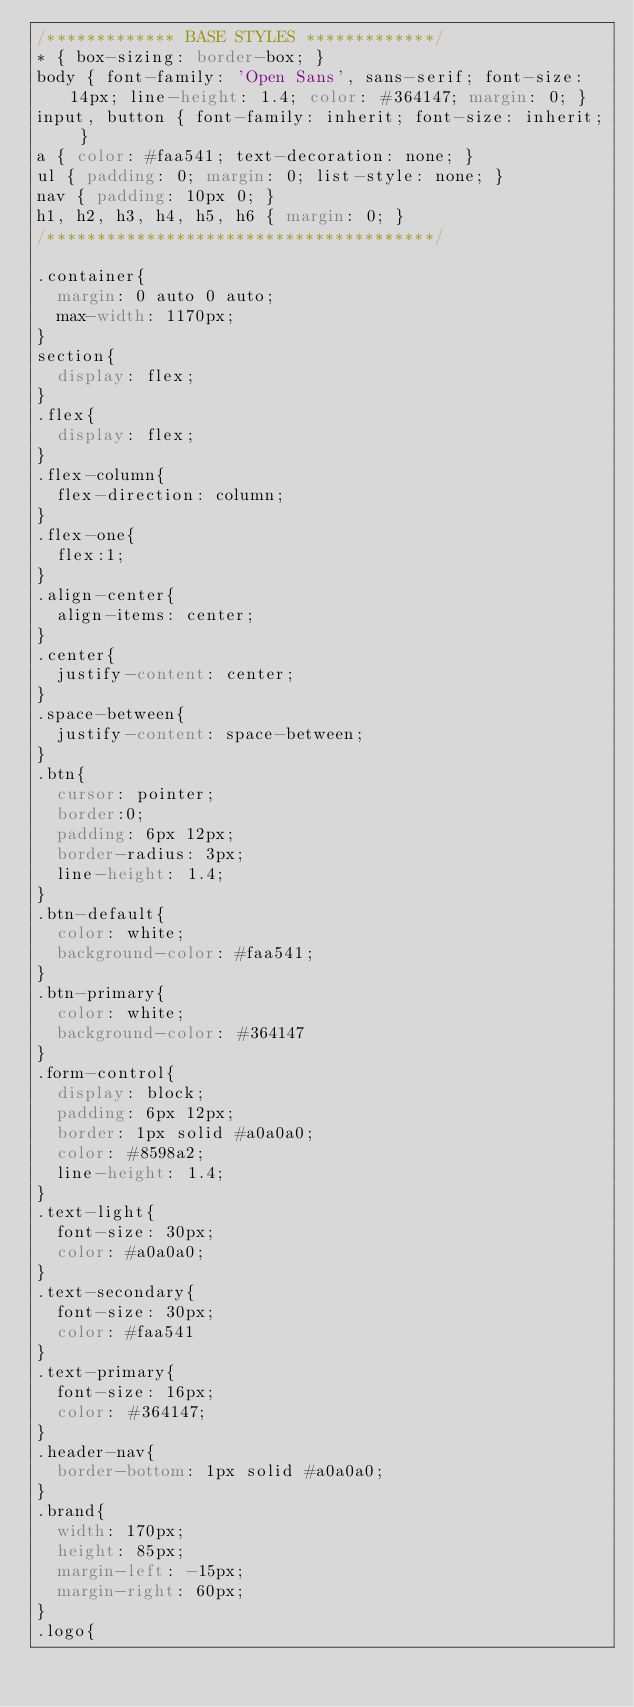<code> <loc_0><loc_0><loc_500><loc_500><_CSS_>/************* BASE STYLES *************/
* { box-sizing: border-box; }
body { font-family: 'Open Sans', sans-serif; font-size: 14px; line-height: 1.4; color: #364147; margin: 0; }
input, button { font-family: inherit; font-size: inherit; }
a { color: #faa541; text-decoration: none; }
ul { padding: 0; margin: 0; list-style: none; }
nav { padding: 10px 0; }
h1, h2, h3, h4, h5, h6 { margin: 0; }
/***************************************/

.container{
  margin: 0 auto 0 auto;
  max-width: 1170px;
}
section{
  display: flex;
}
.flex{
  display: flex;
}
.flex-column{
  flex-direction: column;
}
.flex-one{
  flex:1;
}
.align-center{
  align-items: center;
}
.center{
  justify-content: center;
}
.space-between{
  justify-content: space-between;
}
.btn{
  cursor: pointer;
  border:0;
  padding: 6px 12px;
  border-radius: 3px;
  line-height: 1.4;
}
.btn-default{
  color: white;
  background-color: #faa541;
}
.btn-primary{
  color: white;
  background-color: #364147
}
.form-control{
  display: block;
  padding: 6px 12px;
  border: 1px solid #a0a0a0;
  color: #8598a2;
  line-height: 1.4;
}
.text-light{
  font-size: 30px;
  color: #a0a0a0;
}
.text-secondary{
  font-size: 30px;
  color: #faa541
}
.text-primary{
  font-size: 16px;
  color: #364147;
}
.header-nav{
  border-bottom: 1px solid #a0a0a0;
}
.brand{
  width: 170px;
  height: 85px;
  margin-left: -15px;
  margin-right: 60px;
}
.logo{</code> 